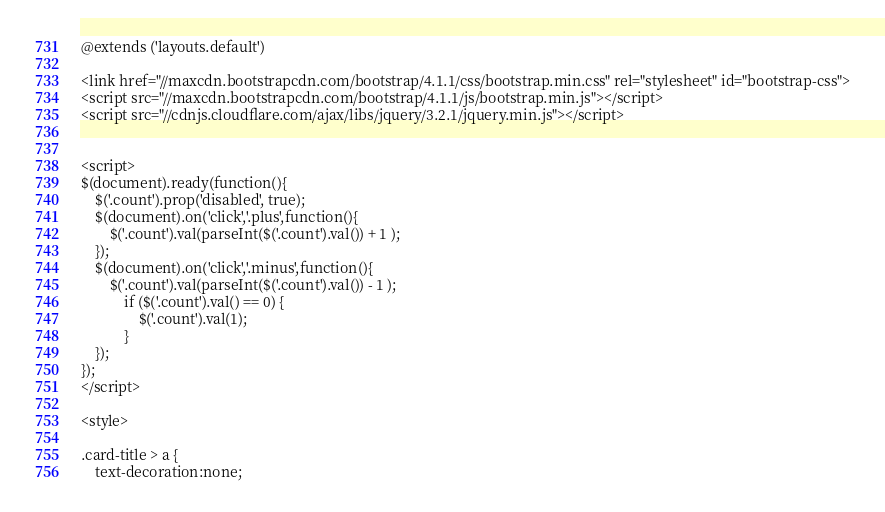<code> <loc_0><loc_0><loc_500><loc_500><_PHP_>@extends ('layouts.default')

<link href="//maxcdn.bootstrapcdn.com/bootstrap/4.1.1/css/bootstrap.min.css" rel="stylesheet" id="bootstrap-css">
<script src="//maxcdn.bootstrapcdn.com/bootstrap/4.1.1/js/bootstrap.min.js"></script>
<script src="//cdnjs.cloudflare.com/ajax/libs/jquery/3.2.1/jquery.min.js"></script>


<script>
$(document).ready(function(){
    $('.count').prop('disabled', true);
    $(document).on('click','.plus',function(){
        $('.count').val(parseInt($('.count').val()) + 1 );
    });
    $(document).on('click','.minus',function(){
        $('.count').val(parseInt($('.count').val()) - 1 );
            if ($('.count').val() == 0) {
                $('.count').val(1);
            }
    });
});
</script>

<style>

.card-title > a {
    text-decoration:none;</code> 